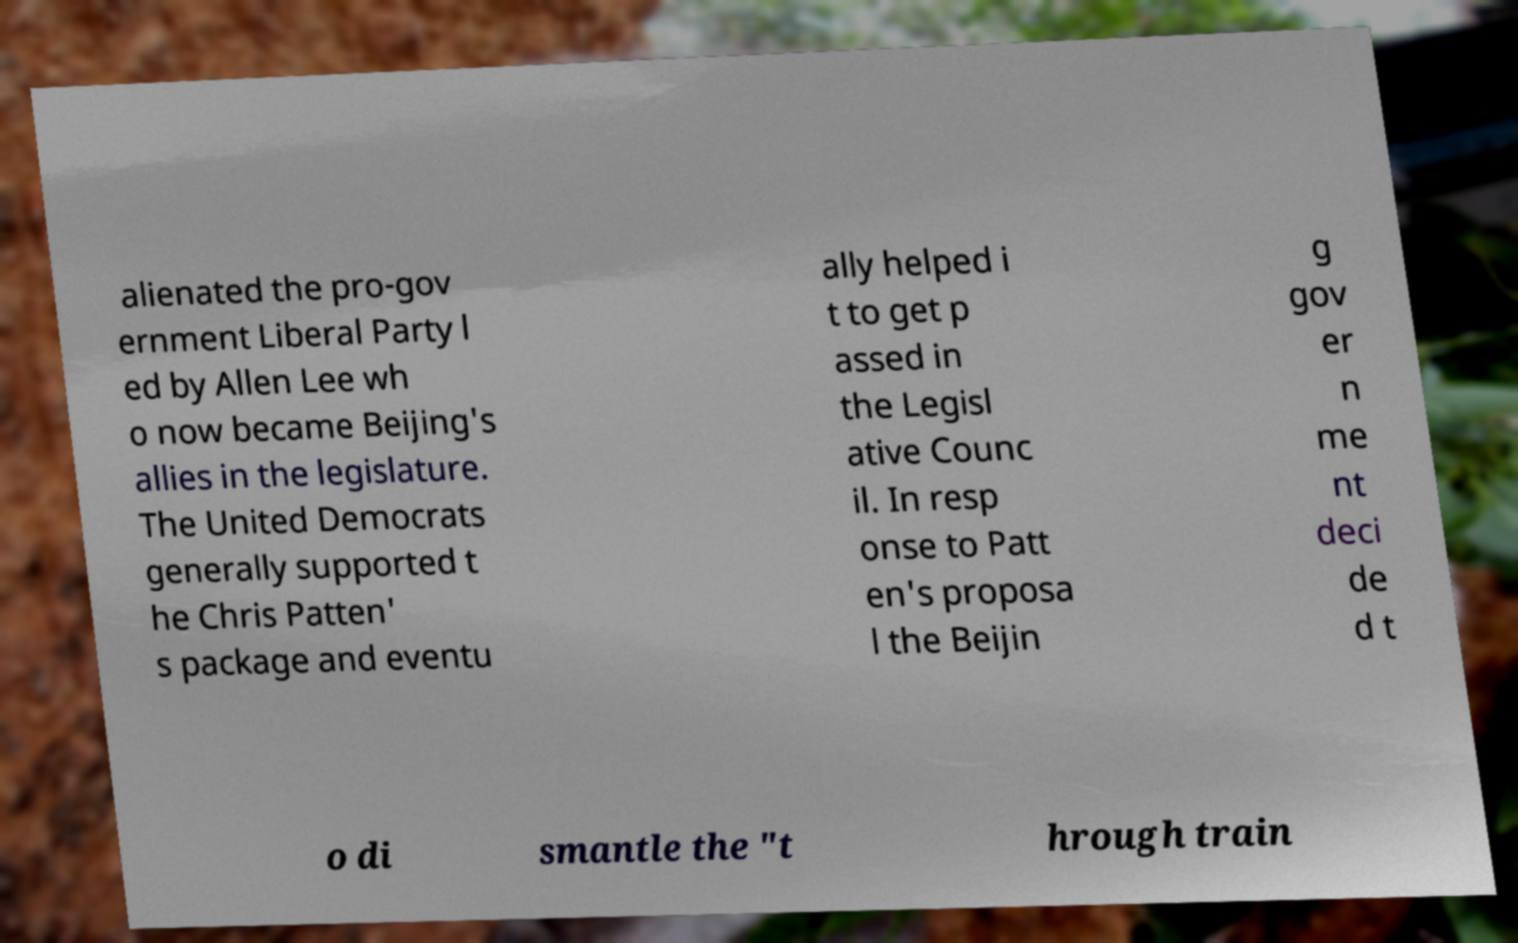Please read and relay the text visible in this image. What does it say? alienated the pro-gov ernment Liberal Party l ed by Allen Lee wh o now became Beijing's allies in the legislature. The United Democrats generally supported t he Chris Patten' s package and eventu ally helped i t to get p assed in the Legisl ative Counc il. In resp onse to Patt en's proposa l the Beijin g gov er n me nt deci de d t o di smantle the "t hrough train 